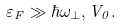<formula> <loc_0><loc_0><loc_500><loc_500>\varepsilon _ { F } \gg \hbar { \omega } _ { \perp } , V _ { 0 } .</formula> 